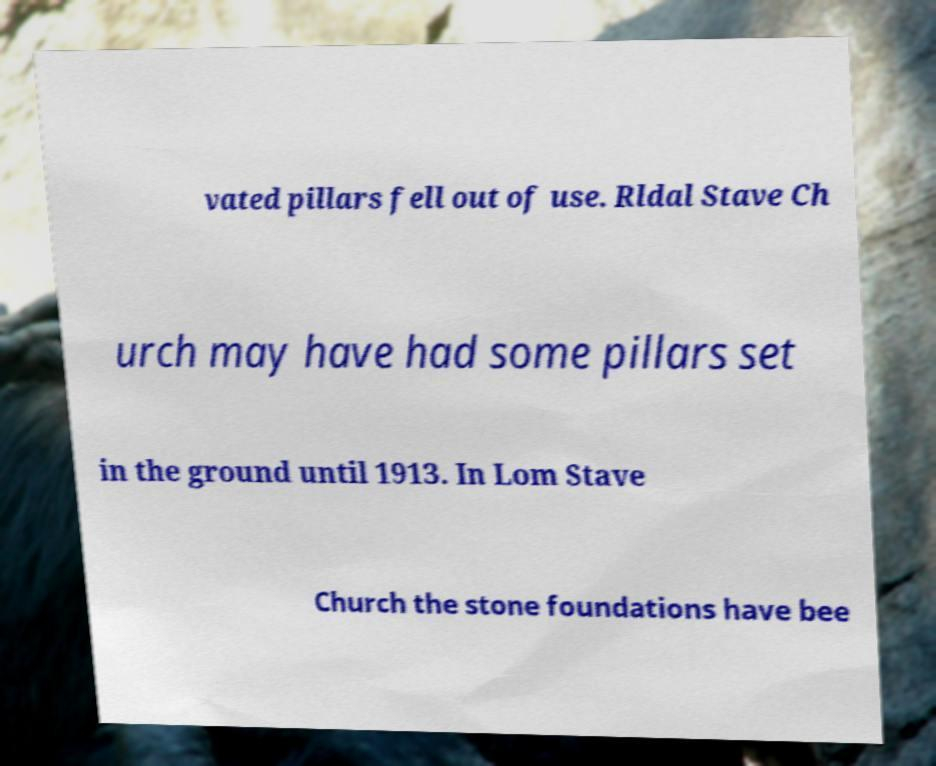Can you accurately transcribe the text from the provided image for me? vated pillars fell out of use. Rldal Stave Ch urch may have had some pillars set in the ground until 1913. In Lom Stave Church the stone foundations have bee 